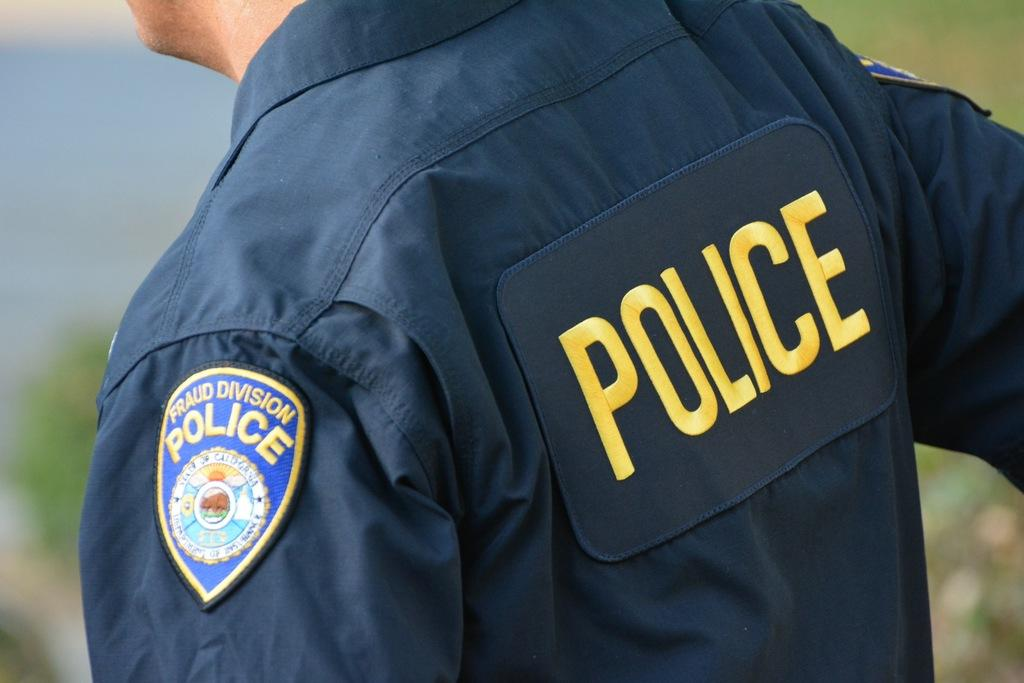Provide a one-sentence caption for the provided image. A police officer that works in the fraud division. 